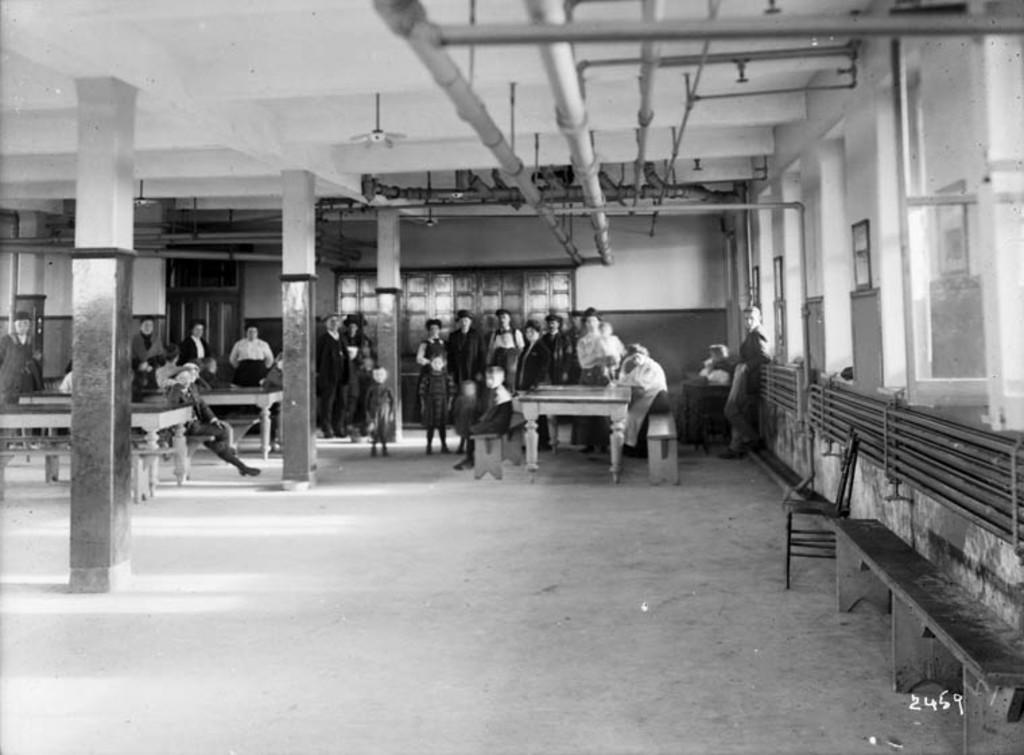What is happening with the people in the image? There are people standing on the floor in the image. Can you describe the age range of the individuals in the image? There are children, men, and women in the image. What is the color scheme of the image? The image is black and white. What type of bear can be seen interacting with the children in the image? There is no bear present in the image; it features people standing on the floor. What question is being asked by the person in the image? There is no person asking a question in the image; it is a static scene with people standing on the floor. 